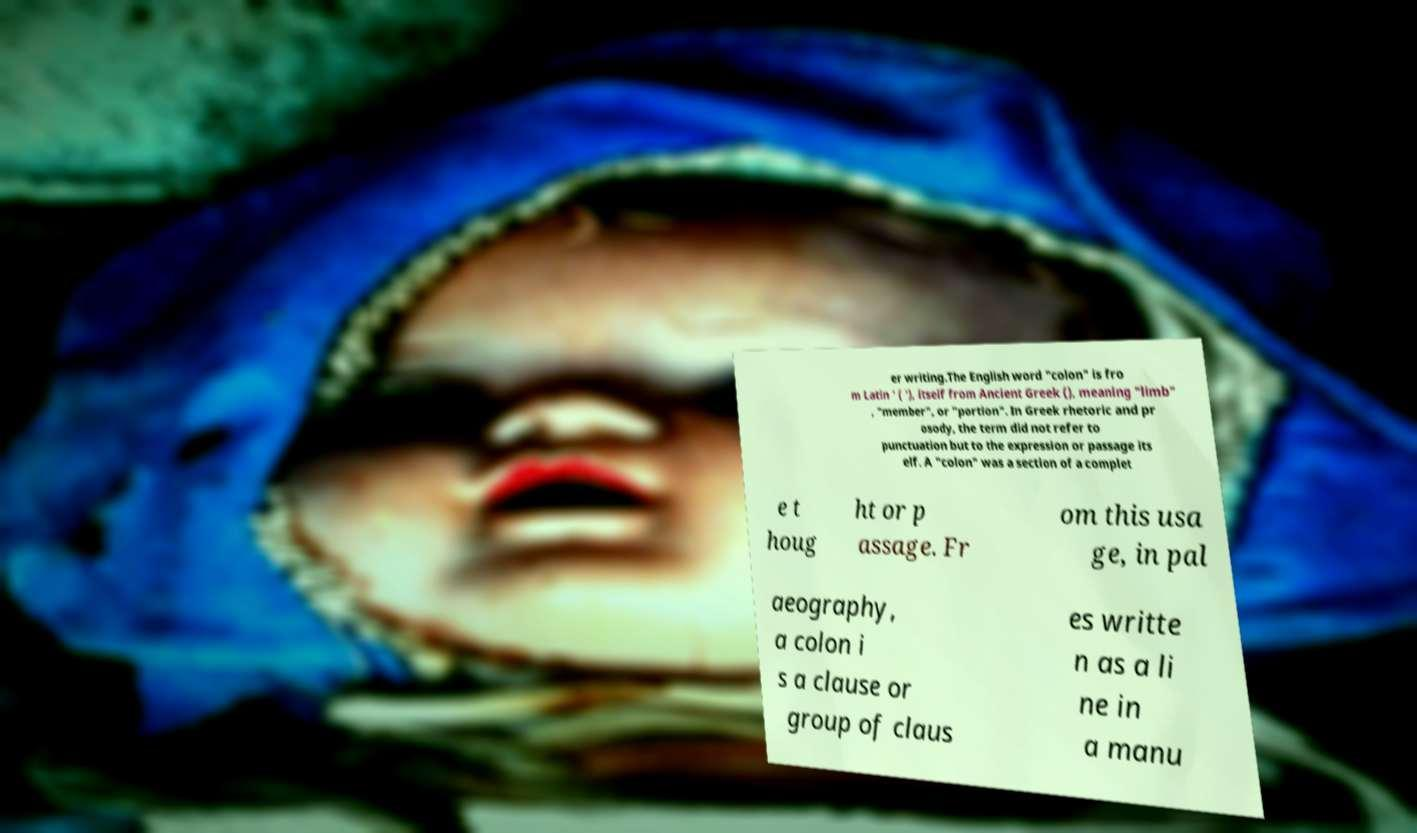There's text embedded in this image that I need extracted. Can you transcribe it verbatim? er writing.The English word "colon" is fro m Latin ' ( '), itself from Ancient Greek (), meaning "limb" , "member", or "portion". In Greek rhetoric and pr osody, the term did not refer to punctuation but to the expression or passage its elf. A "colon" was a section of a complet e t houg ht or p assage. Fr om this usa ge, in pal aeography, a colon i s a clause or group of claus es writte n as a li ne in a manu 